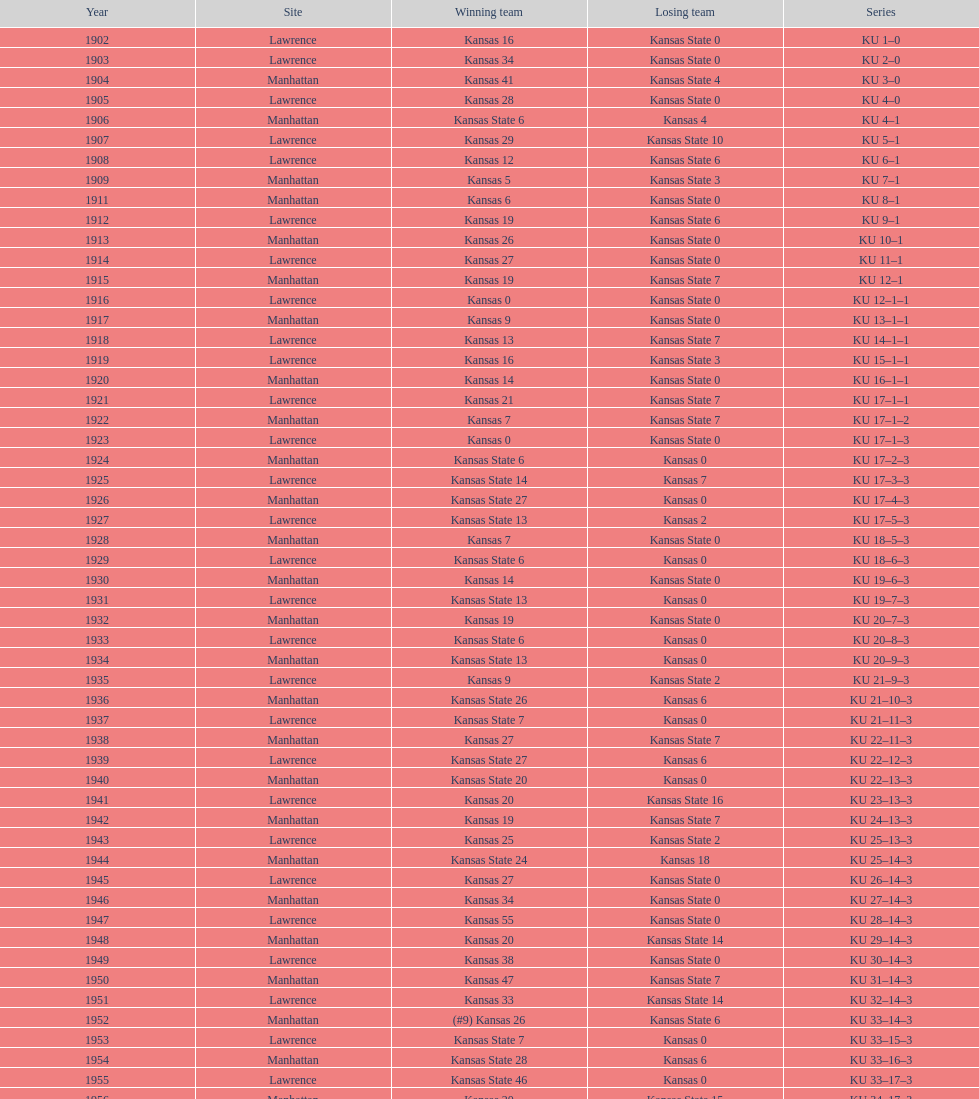Between kansas and kansas state, which team had the highest number of victories in the 1950s? Kansas. 